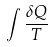Convert formula to latex. <formula><loc_0><loc_0><loc_500><loc_500>\int \frac { \delta Q } { T }</formula> 